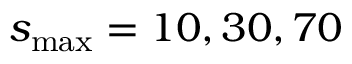<formula> <loc_0><loc_0><loc_500><loc_500>s _ { \max } = 1 0 , 3 0 , 7 0</formula> 